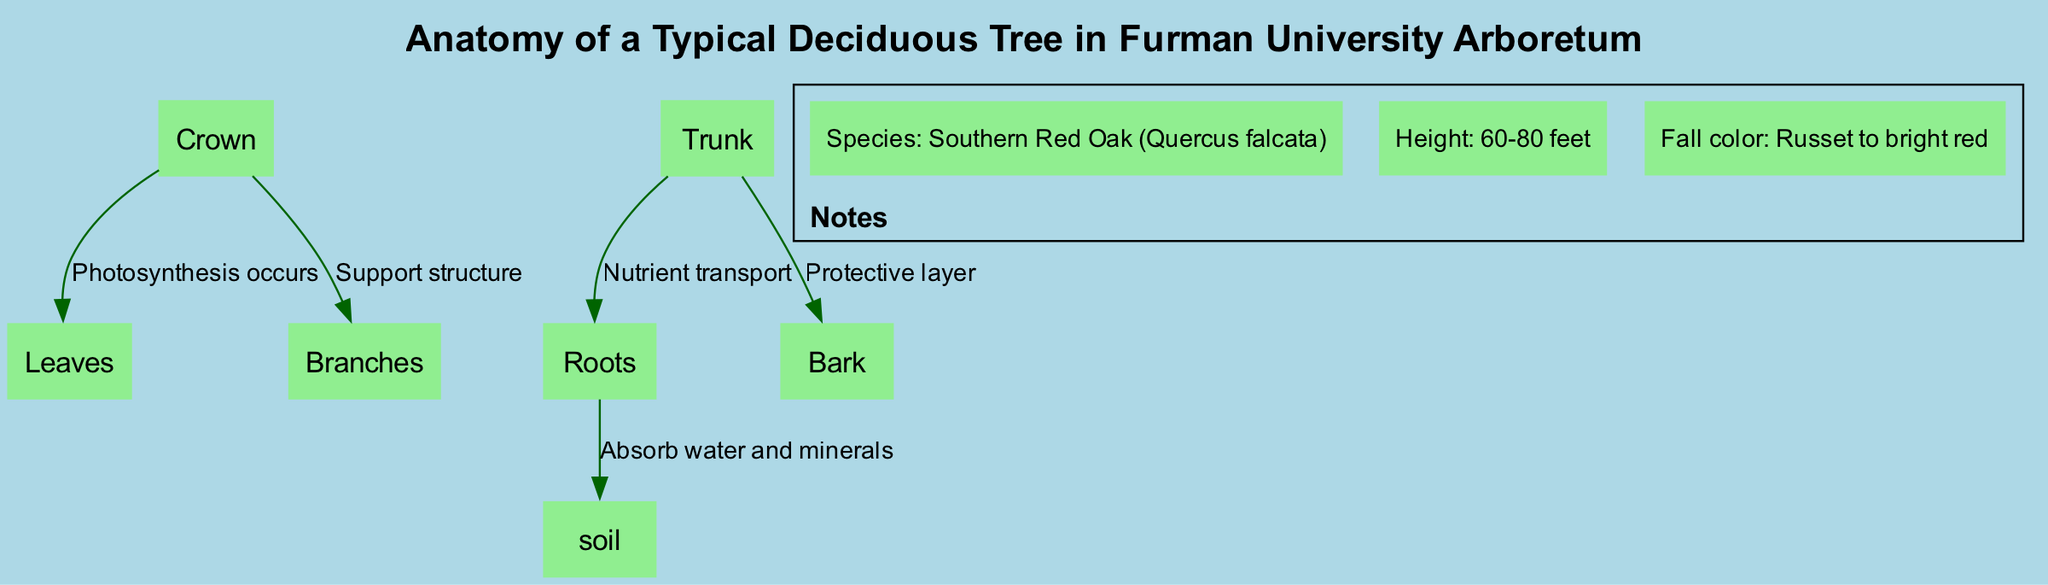What is the title of the diagram? The title of the diagram is explicitly given in the data provided. It is presented at the top of the diagram, allowing viewers to understand the overall focus of the content.
Answer: Anatomy of a Typical Deciduous Tree in Furman University Arboretum How many nodes appear in the diagram? The diagram data lists the nodes under the "nodes" section. Counting these nodes reveals the total number of distinct components being represented in the diagram.
Answer: 6 What is the function of the leaves in the crown? The diagram indicates the relationship between the crown and the leaves. Specifically, the label on the edge connecting these two nodes specifies the process that occurs between them, which is essential for the tree's survival.
Answer: Photosynthesis occurs What is the protective layer of the trunk called? The diagram includes a specific edge between the trunk and bark. This edge is labeled, indicating the role of the bark as it relates to the trunk.
Answer: Bark What do the roots absorb from the soil? According to the edge connecting the roots to the soil, the relationship is labeled, defining what is taken from the soil and emphasizing the roots' crucial function in supporting the tree's health.
Answer: Water and minerals What structure supports the crown of the tree? The diagram connects the crown to the branches, and the edge is labeled to describe the role of this relationship. Identifying this link clarifies which part of the tree is responsible for providing support to the crown.
Answer: Branches Which part of the tree is responsible for nutrient transport? By examining the edge connecting the trunk to the roots, the relationship is labeled to identify the function of the trunk in regards to its connection with the roots. This helps clarify how the tree gathers resources.
Answer: Nutrient transport What color do the leaves of this tree turn in fall? The information regarding fall color is included in the notes section of the diagram. This specific detail stands out, providing additional insight into the behavioral characteristics of the tree throughout the seasons.
Answer: Russet to bright red What is the height range of the Southern Red Oak? One of the notes provides specific quantitative information regarding the height of the tree species represented in the diagram, allowing viewers to understand the typical size of this tree in its mature form.
Answer: 60-80 feet 